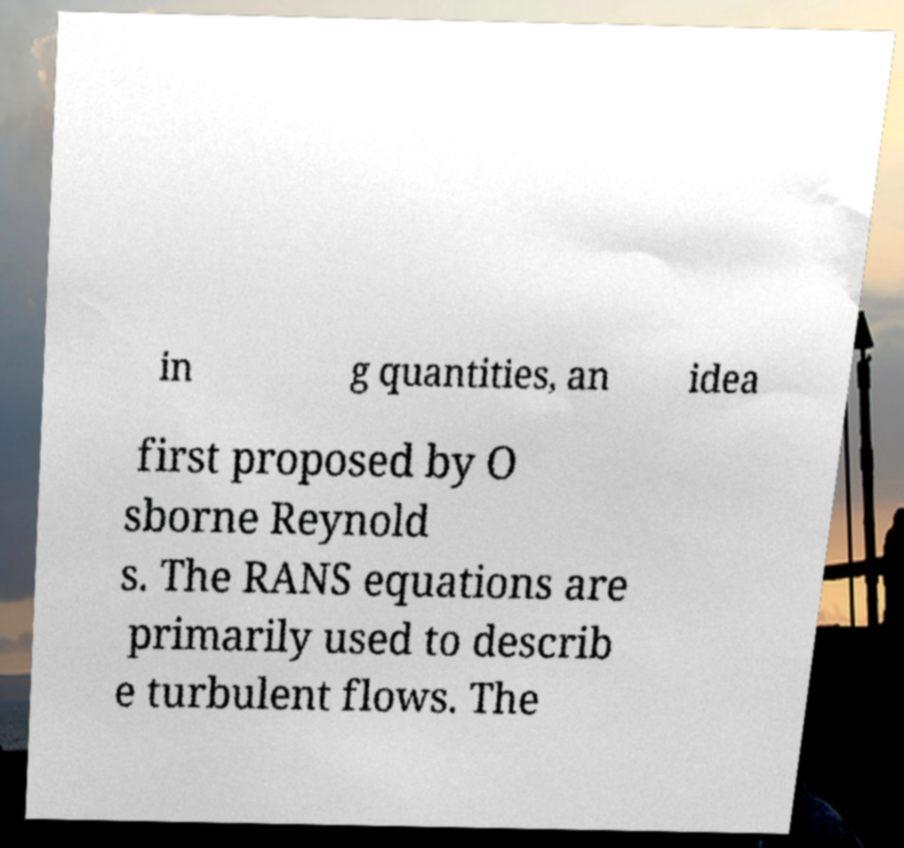What messages or text are displayed in this image? I need them in a readable, typed format. in g quantities, an idea first proposed by O sborne Reynold s. The RANS equations are primarily used to describ e turbulent flows. The 